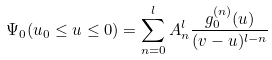<formula> <loc_0><loc_0><loc_500><loc_500>\Psi _ { 0 } ( u _ { 0 } \leq u \leq 0 ) = \sum _ { n = 0 } ^ { l } A _ { n } ^ { l } \frac { g _ { 0 } ^ { ( n ) } ( u ) } { ( v - u ) ^ { l - n } }</formula> 